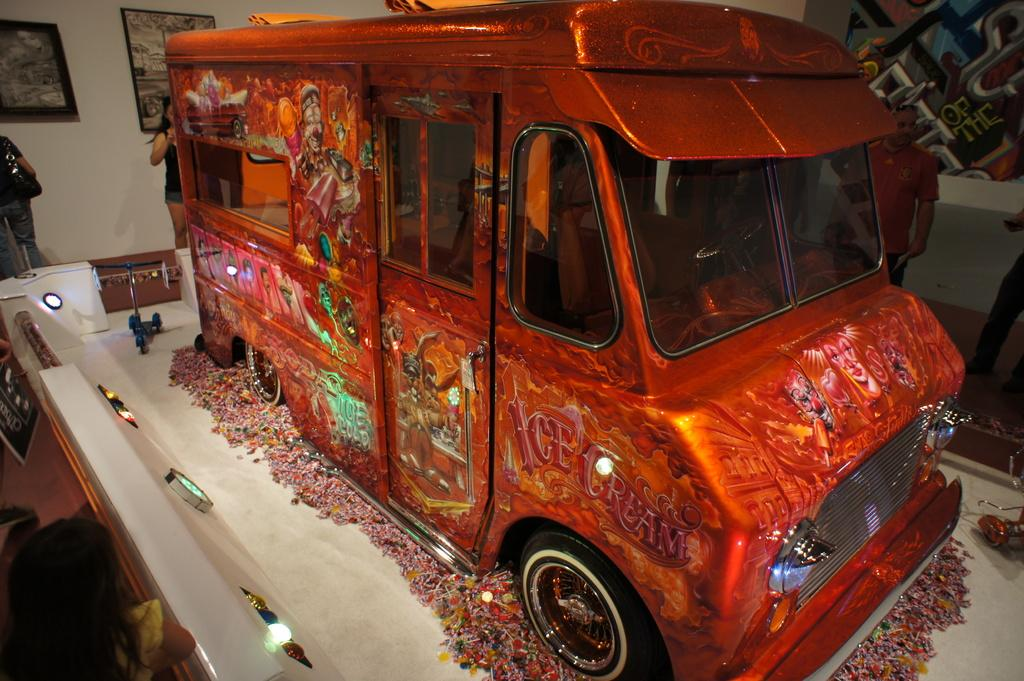What type of vehicle is in the image? There is a colorful design vehicle in the image. Can you describe the people in the image? There are persons visible in the top left of the image. What is present in the background of the image? There is a wall in the image. What is attached to the wall? Photo frames are attached to the wall. What type of kite is being flown by the persons in the image? There is no kite visible in the image; the persons are not engaged in any kite-flying activity. 